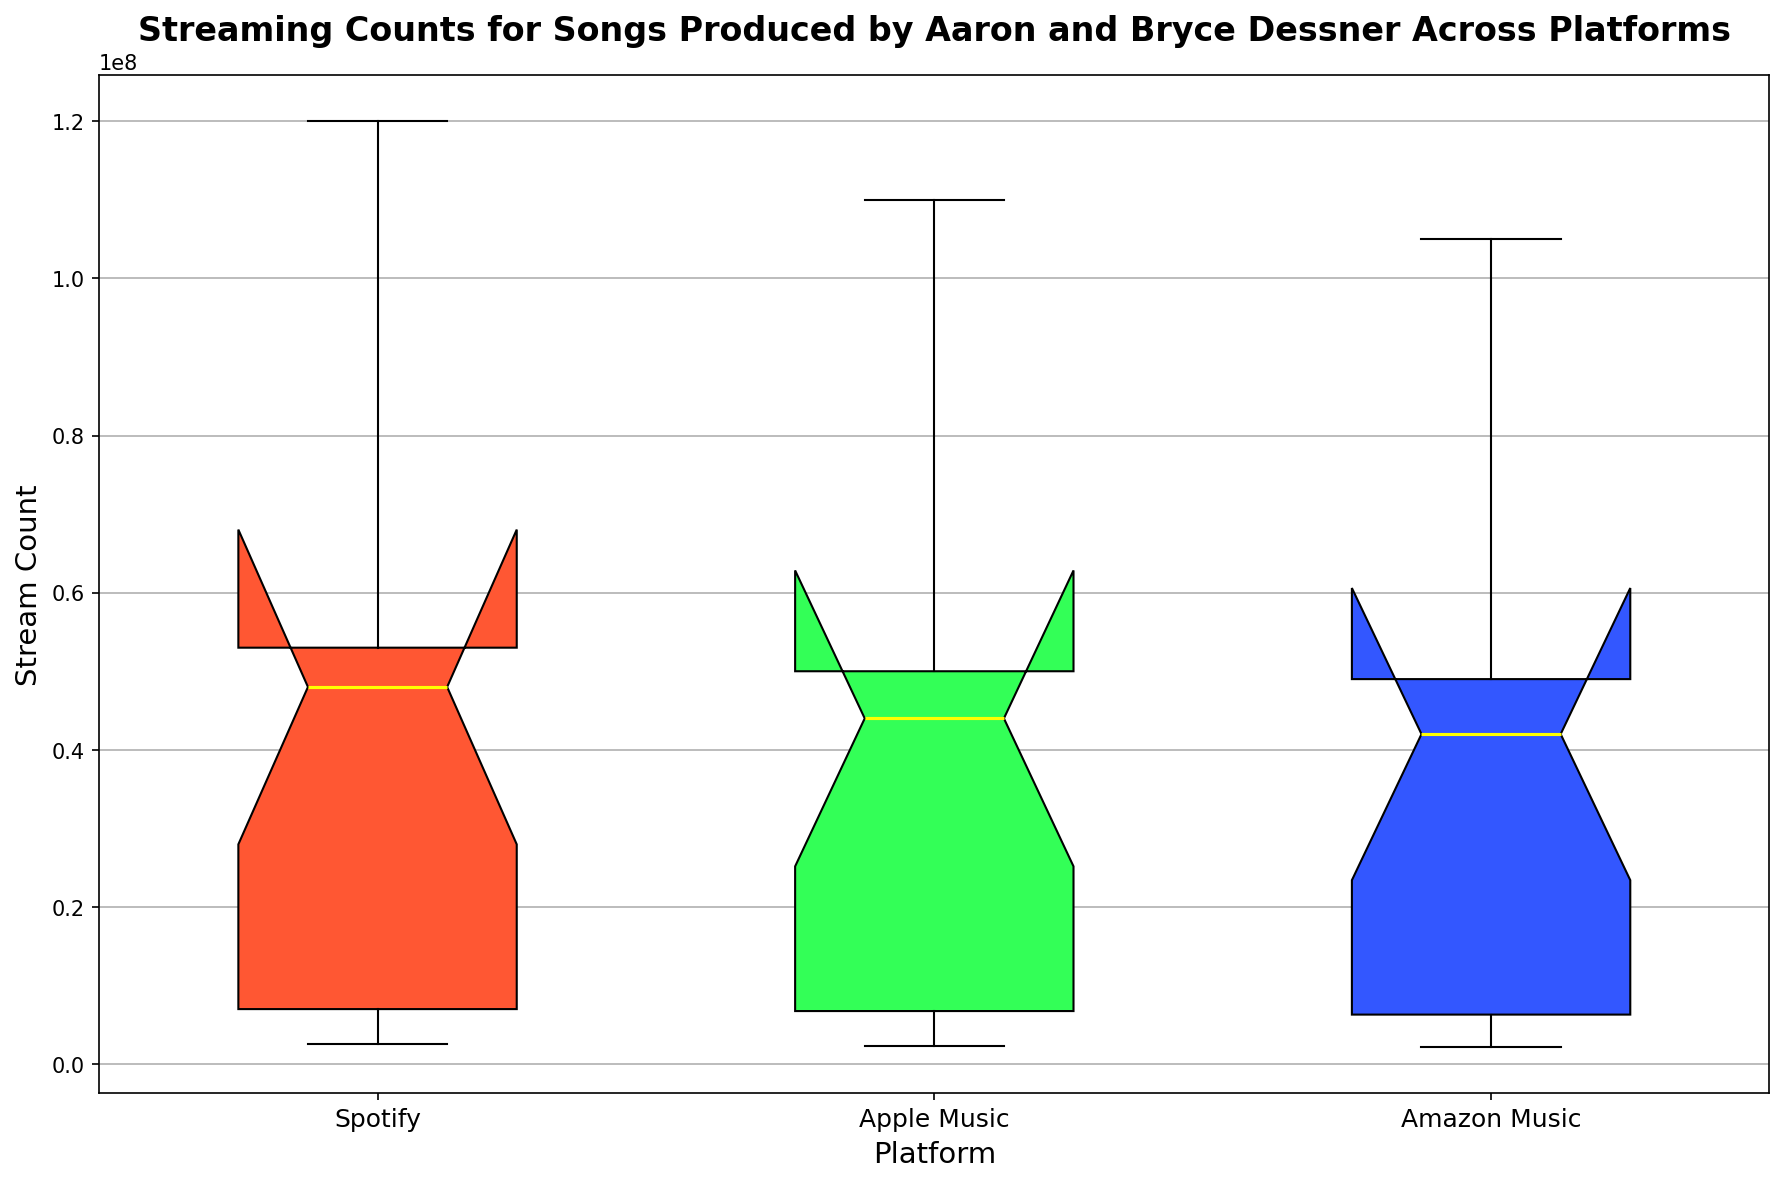What is the median streaming count for Apple Music? To find the median streaming count for Apple Music, locate the middle value of the box plot representing Apple Music, which is indicated by the yellow line inside the box.
Answer: 44,500,000 Which platform has the highest median streaming count? Compare the yellow lines (medians) inside each box plot for the different platforms. The box plot with the highest yellow line indicates the platform with the highest median streaming count.
Answer: Spotify What is the interquartile range (IQR) for Spotify? The IQR is the difference between the third quartile (top of the box) and the first quartile (bottom of the box) in the box plot for Spotify. Measure this distance visually on the y-axis.
Answer: 50,000,000 Which platform shows the largest variability in streaming counts? Look at the width of the interquartile range (IQR) and the overall range (whiskers length) of the box plots. The platform with the largest variability will have the largest IQR and whisker length.
Answer: Spotify Is there any platform where the median streaming count is the same as another platform's first quartile? Compare the yellow lines (medians) and the bottom of the boxes (first quartiles) of the different platforms to see if any median aligns at the same value as another platform's first quartile.
Answer: No Which platform appears to have the most outliers in streaming counts? Identify the box plot that has the most data points falling outside the whiskers (outliers are usually marked with dots or other markers).
Answer: No clear outliers are shown How do the third quartile values for Apple Music and Amazon Music compare? Compare the positions of the tops of the boxes for both Apple Music and Amazon Music to see which is higher.
Answer: Apple Music has a higher third quartile value What's the difference in median streaming counts between Spotify and Amazon Music? Find the yellow line (median) values for both Spotify and Amazon Music and calculate the difference between these values.
Answer: 6,000,000 Which color represents the box plot for Amazon Music, and what is its significance in showing differences? Identify the color of the box for Amazon Music and discuss that different colors distinguish platforms, aiding in visual comparison.
Answer: Blue; helps differentiate Amazon Music from others 